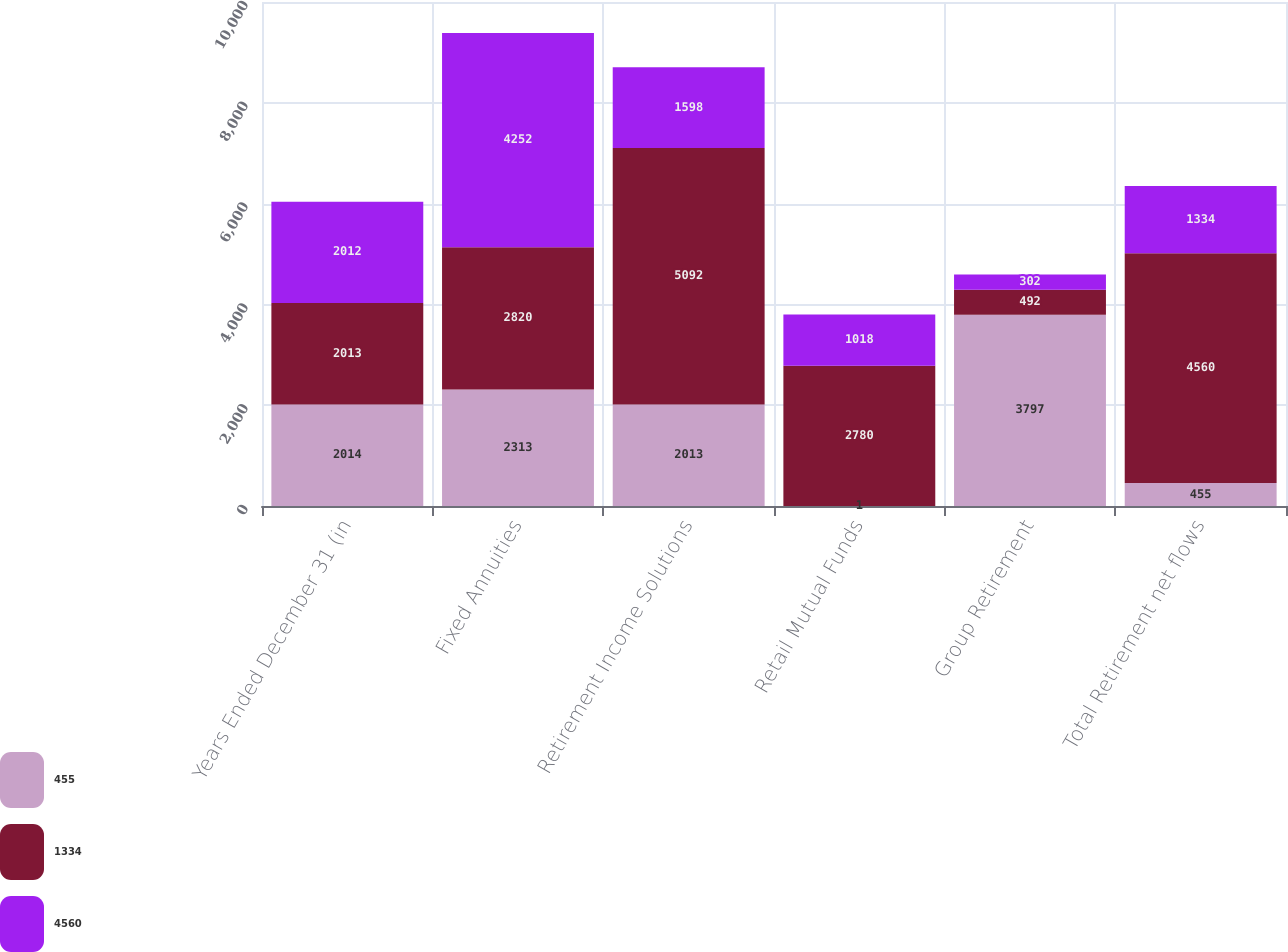Convert chart to OTSL. <chart><loc_0><loc_0><loc_500><loc_500><stacked_bar_chart><ecel><fcel>Years Ended December 31 (in<fcel>Fixed Annuities<fcel>Retirement Income Solutions<fcel>Retail Mutual Funds<fcel>Group Retirement<fcel>Total Retirement net flows<nl><fcel>455<fcel>2014<fcel>2313<fcel>2013<fcel>1<fcel>3797<fcel>455<nl><fcel>1334<fcel>2013<fcel>2820<fcel>5092<fcel>2780<fcel>492<fcel>4560<nl><fcel>4560<fcel>2012<fcel>4252<fcel>1598<fcel>1018<fcel>302<fcel>1334<nl></chart> 